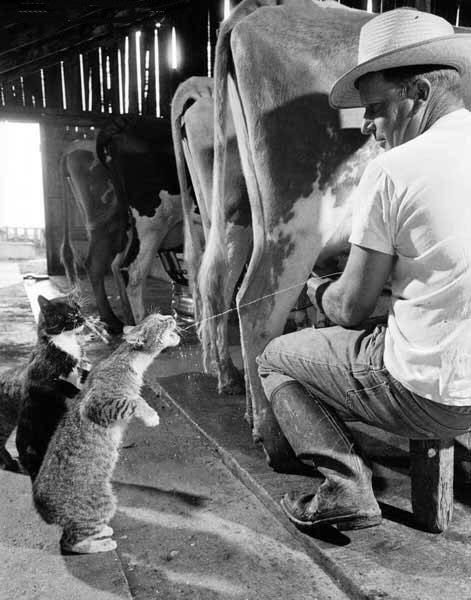What color is the photo?
Give a very brief answer. Black and white. Who is taking up more space on the bench?
Be succinct. Man. How many cows are here?
Keep it brief. 4. What is the cat drinking?
Concise answer only. Milk. 